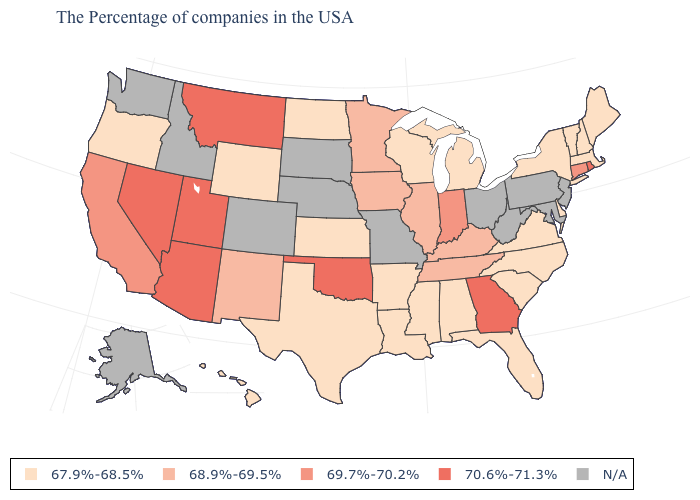Does the first symbol in the legend represent the smallest category?
Answer briefly. Yes. What is the value of South Carolina?
Write a very short answer. 67.9%-68.5%. What is the value of North Dakota?
Give a very brief answer. 67.9%-68.5%. What is the value of Delaware?
Give a very brief answer. 67.9%-68.5%. What is the lowest value in the South?
Short answer required. 67.9%-68.5%. Name the states that have a value in the range 67.9%-68.5%?
Be succinct. Maine, Massachusetts, New Hampshire, Vermont, New York, Delaware, Virginia, North Carolina, South Carolina, Florida, Michigan, Alabama, Wisconsin, Mississippi, Louisiana, Arkansas, Kansas, Texas, North Dakota, Wyoming, Oregon, Hawaii. Name the states that have a value in the range N/A?
Answer briefly. New Jersey, Maryland, Pennsylvania, West Virginia, Ohio, Missouri, Nebraska, South Dakota, Colorado, Idaho, Washington, Alaska. Does the first symbol in the legend represent the smallest category?
Short answer required. Yes. Which states have the lowest value in the USA?
Quick response, please. Maine, Massachusetts, New Hampshire, Vermont, New York, Delaware, Virginia, North Carolina, South Carolina, Florida, Michigan, Alabama, Wisconsin, Mississippi, Louisiana, Arkansas, Kansas, Texas, North Dakota, Wyoming, Oregon, Hawaii. What is the value of Wisconsin?
Quick response, please. 67.9%-68.5%. How many symbols are there in the legend?
Quick response, please. 5. What is the value of New Hampshire?
Give a very brief answer. 67.9%-68.5%. Name the states that have a value in the range 70.6%-71.3%?
Be succinct. Rhode Island, Georgia, Oklahoma, Utah, Montana, Arizona, Nevada. Name the states that have a value in the range 69.7%-70.2%?
Write a very short answer. Connecticut, Indiana, California. 